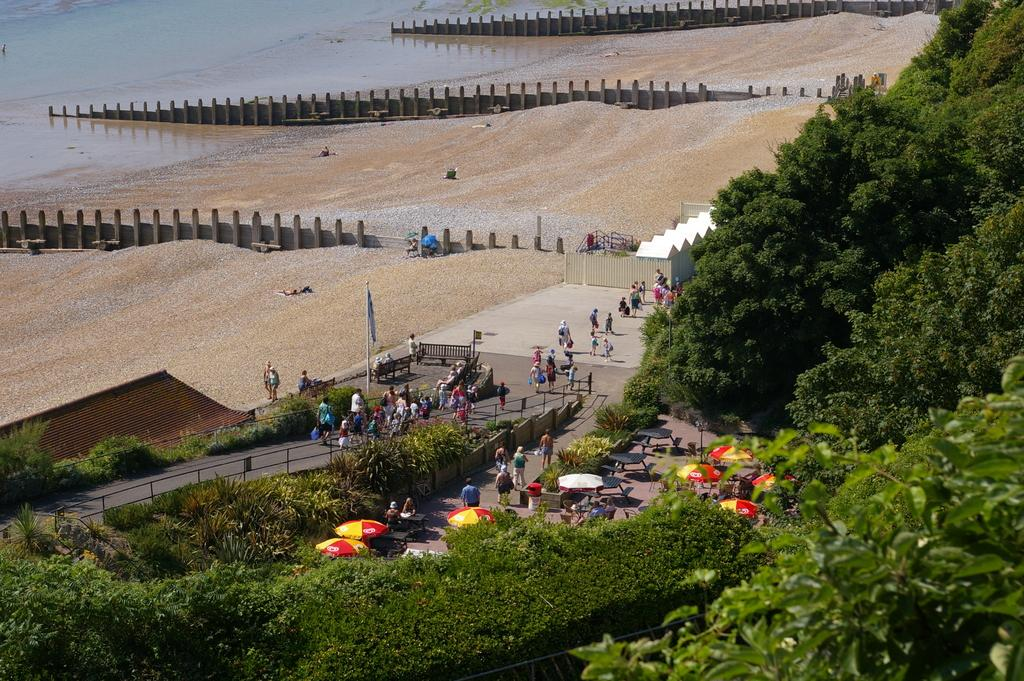What type of vegetation is present in the image? There are trees in the image. What objects are present for protection from the sun or rain? There are umbrellas in the image. What type of seating is available in the image? There are benches in the image. What can be observed about the people in the image? There are people standing in the center of the image. What is visible in the background of the image? There is ground and water visible in the background of the image. Can you tell me how much glue is being used by the bear in the image? There is no bear or glue present in the image. What type of water activity is the bear participating in the image? There is no bear present in the image, so it is not possible to answer that question. 